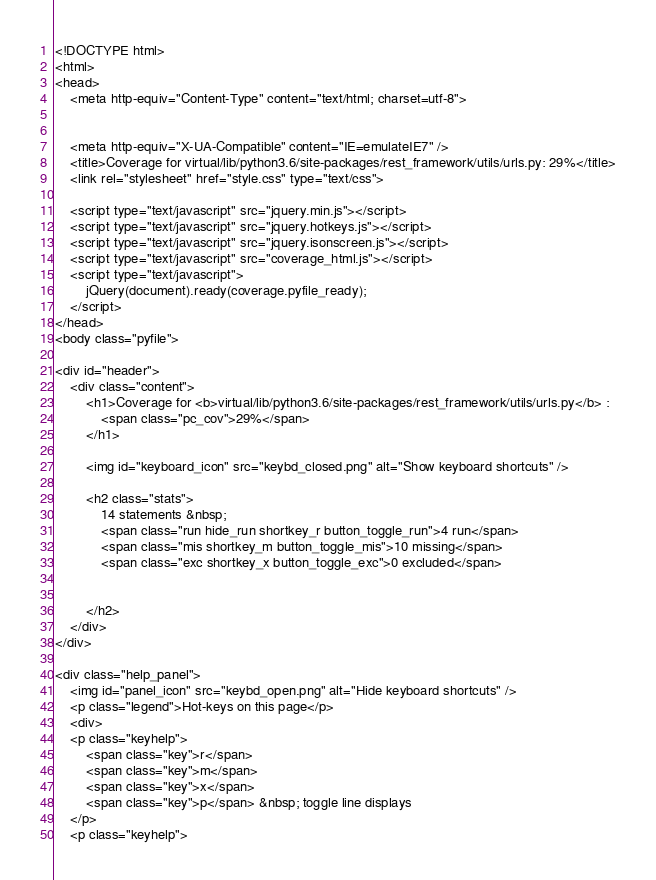Convert code to text. <code><loc_0><loc_0><loc_500><loc_500><_HTML_>


<!DOCTYPE html>
<html>
<head>
    <meta http-equiv="Content-Type" content="text/html; charset=utf-8">
    
    
    <meta http-equiv="X-UA-Compatible" content="IE=emulateIE7" />
    <title>Coverage for virtual/lib/python3.6/site-packages/rest_framework/utils/urls.py: 29%</title>
    <link rel="stylesheet" href="style.css" type="text/css">
    
    <script type="text/javascript" src="jquery.min.js"></script>
    <script type="text/javascript" src="jquery.hotkeys.js"></script>
    <script type="text/javascript" src="jquery.isonscreen.js"></script>
    <script type="text/javascript" src="coverage_html.js"></script>
    <script type="text/javascript">
        jQuery(document).ready(coverage.pyfile_ready);
    </script>
</head>
<body class="pyfile">

<div id="header">
    <div class="content">
        <h1>Coverage for <b>virtual/lib/python3.6/site-packages/rest_framework/utils/urls.py</b> :
            <span class="pc_cov">29%</span>
        </h1>

        <img id="keyboard_icon" src="keybd_closed.png" alt="Show keyboard shortcuts" />

        <h2 class="stats">
            14 statements &nbsp;
            <span class="run hide_run shortkey_r button_toggle_run">4 run</span>
            <span class="mis shortkey_m button_toggle_mis">10 missing</span>
            <span class="exc shortkey_x button_toggle_exc">0 excluded</span>

            
        </h2>
    </div>
</div>

<div class="help_panel">
    <img id="panel_icon" src="keybd_open.png" alt="Hide keyboard shortcuts" />
    <p class="legend">Hot-keys on this page</p>
    <div>
    <p class="keyhelp">
        <span class="key">r</span>
        <span class="key">m</span>
        <span class="key">x</span>
        <span class="key">p</span> &nbsp; toggle line displays
    </p>
    <p class="keyhelp"></code> 